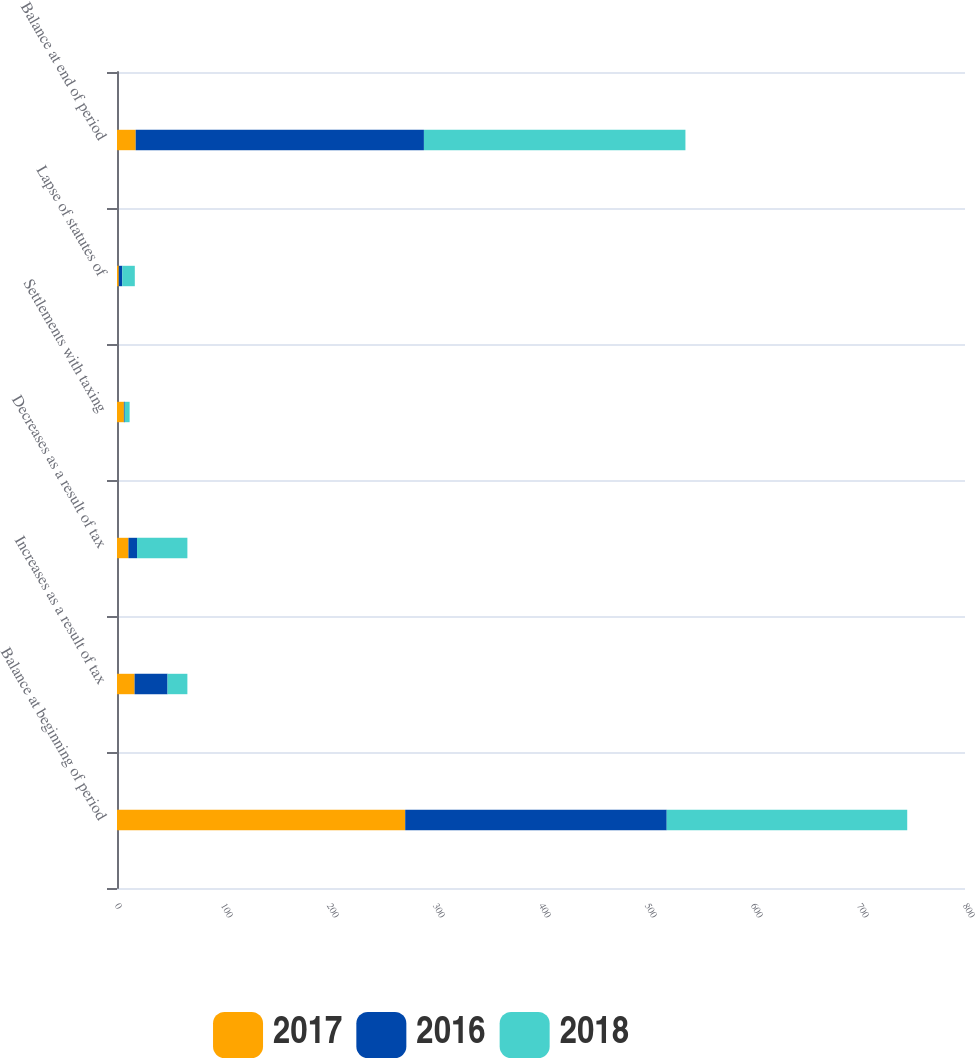Convert chart. <chart><loc_0><loc_0><loc_500><loc_500><stacked_bar_chart><ecel><fcel>Balance at beginning of period<fcel>Increases as a result of tax<fcel>Decreases as a result of tax<fcel>Settlements with taxing<fcel>Lapse of statutes of<fcel>Balance at end of period<nl><fcel>2017<fcel>271.9<fcel>16.6<fcel>10.8<fcel>6.5<fcel>1.7<fcel>17.65<nl><fcel>2016<fcel>246.7<fcel>31.1<fcel>8.1<fcel>0.8<fcel>3.3<fcel>271.9<nl><fcel>2018<fcel>226.9<fcel>18.7<fcel>47.5<fcel>4.6<fcel>11.8<fcel>246.7<nl></chart> 